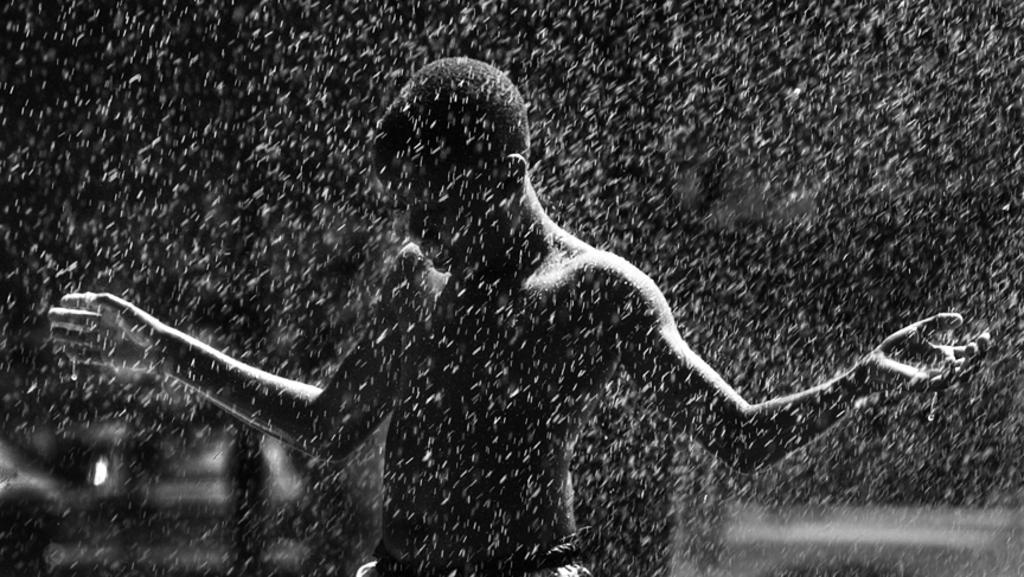What is the color scheme of the image? The image is black and white. Can you describe the person in the image? There is a man standing in the image. What is happening in the background of the image? It appears to be raining in the image. What color is the background of the image? The background of the image is black. Is there any indication that the image has been altered or edited? The image might be edited. What type of goat can be seen grazing in the image? There is no goat present in the image; it is a black and white image of a man standing in the rain. What is the reason for the flame in the image? There is no flame present in the image; it is a black and white image of a man standing in the rain. 